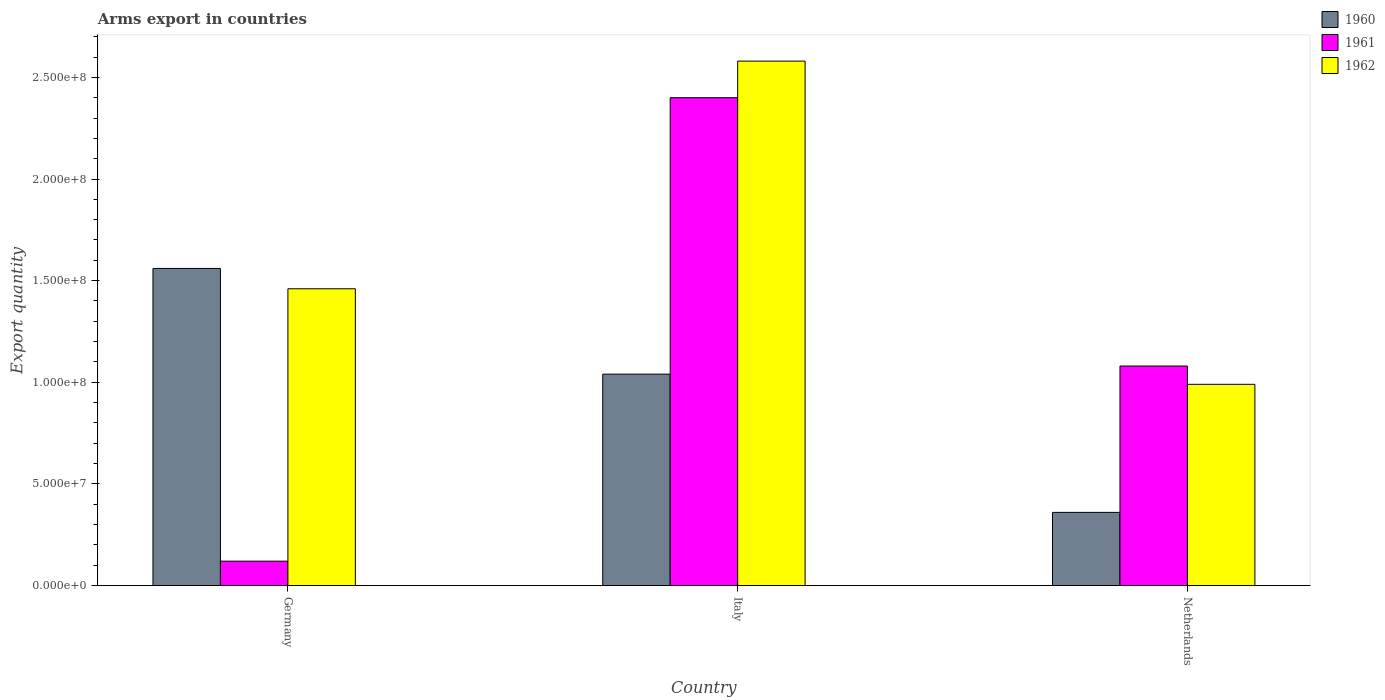Are the number of bars on each tick of the X-axis equal?
Your response must be concise. Yes. What is the label of the 1st group of bars from the left?
Provide a short and direct response. Germany. What is the total arms export in 1961 in Italy?
Your answer should be compact. 2.40e+08. Across all countries, what is the maximum total arms export in 1960?
Provide a succinct answer. 1.56e+08. Across all countries, what is the minimum total arms export in 1962?
Your answer should be very brief. 9.90e+07. What is the total total arms export in 1961 in the graph?
Offer a terse response. 3.60e+08. What is the difference between the total arms export in 1962 in Germany and that in Italy?
Your response must be concise. -1.12e+08. What is the difference between the total arms export in 1960 in Italy and the total arms export in 1961 in Netherlands?
Keep it short and to the point. -4.00e+06. What is the average total arms export in 1960 per country?
Ensure brevity in your answer.  9.87e+07. What is the difference between the total arms export of/in 1960 and total arms export of/in 1961 in Netherlands?
Your response must be concise. -7.20e+07. What is the ratio of the total arms export in 1961 in Germany to that in Netherlands?
Your response must be concise. 0.11. Is the difference between the total arms export in 1960 in Italy and Netherlands greater than the difference between the total arms export in 1961 in Italy and Netherlands?
Offer a very short reply. No. What is the difference between the highest and the second highest total arms export in 1962?
Give a very brief answer. 1.12e+08. What is the difference between the highest and the lowest total arms export in 1961?
Offer a very short reply. 2.28e+08. What does the 2nd bar from the right in Italy represents?
Offer a terse response. 1961. How many countries are there in the graph?
Provide a succinct answer. 3. Does the graph contain any zero values?
Provide a succinct answer. No. Does the graph contain grids?
Offer a very short reply. No. How many legend labels are there?
Ensure brevity in your answer.  3. How are the legend labels stacked?
Give a very brief answer. Vertical. What is the title of the graph?
Your answer should be compact. Arms export in countries. What is the label or title of the X-axis?
Provide a succinct answer. Country. What is the label or title of the Y-axis?
Your answer should be compact. Export quantity. What is the Export quantity of 1960 in Germany?
Your answer should be compact. 1.56e+08. What is the Export quantity of 1961 in Germany?
Keep it short and to the point. 1.20e+07. What is the Export quantity in 1962 in Germany?
Your answer should be compact. 1.46e+08. What is the Export quantity of 1960 in Italy?
Keep it short and to the point. 1.04e+08. What is the Export quantity in 1961 in Italy?
Keep it short and to the point. 2.40e+08. What is the Export quantity in 1962 in Italy?
Keep it short and to the point. 2.58e+08. What is the Export quantity in 1960 in Netherlands?
Make the answer very short. 3.60e+07. What is the Export quantity of 1961 in Netherlands?
Offer a very short reply. 1.08e+08. What is the Export quantity in 1962 in Netherlands?
Your response must be concise. 9.90e+07. Across all countries, what is the maximum Export quantity in 1960?
Give a very brief answer. 1.56e+08. Across all countries, what is the maximum Export quantity in 1961?
Your answer should be compact. 2.40e+08. Across all countries, what is the maximum Export quantity of 1962?
Offer a terse response. 2.58e+08. Across all countries, what is the minimum Export quantity of 1960?
Ensure brevity in your answer.  3.60e+07. Across all countries, what is the minimum Export quantity of 1961?
Your response must be concise. 1.20e+07. Across all countries, what is the minimum Export quantity of 1962?
Keep it short and to the point. 9.90e+07. What is the total Export quantity in 1960 in the graph?
Give a very brief answer. 2.96e+08. What is the total Export quantity of 1961 in the graph?
Provide a short and direct response. 3.60e+08. What is the total Export quantity in 1962 in the graph?
Your response must be concise. 5.03e+08. What is the difference between the Export quantity of 1960 in Germany and that in Italy?
Keep it short and to the point. 5.20e+07. What is the difference between the Export quantity in 1961 in Germany and that in Italy?
Give a very brief answer. -2.28e+08. What is the difference between the Export quantity of 1962 in Germany and that in Italy?
Your answer should be very brief. -1.12e+08. What is the difference between the Export quantity of 1960 in Germany and that in Netherlands?
Offer a terse response. 1.20e+08. What is the difference between the Export quantity in 1961 in Germany and that in Netherlands?
Make the answer very short. -9.60e+07. What is the difference between the Export quantity in 1962 in Germany and that in Netherlands?
Ensure brevity in your answer.  4.70e+07. What is the difference between the Export quantity of 1960 in Italy and that in Netherlands?
Your answer should be compact. 6.80e+07. What is the difference between the Export quantity in 1961 in Italy and that in Netherlands?
Your answer should be very brief. 1.32e+08. What is the difference between the Export quantity of 1962 in Italy and that in Netherlands?
Keep it short and to the point. 1.59e+08. What is the difference between the Export quantity of 1960 in Germany and the Export quantity of 1961 in Italy?
Keep it short and to the point. -8.40e+07. What is the difference between the Export quantity of 1960 in Germany and the Export quantity of 1962 in Italy?
Provide a short and direct response. -1.02e+08. What is the difference between the Export quantity in 1961 in Germany and the Export quantity in 1962 in Italy?
Keep it short and to the point. -2.46e+08. What is the difference between the Export quantity of 1960 in Germany and the Export quantity of 1961 in Netherlands?
Offer a terse response. 4.80e+07. What is the difference between the Export quantity of 1960 in Germany and the Export quantity of 1962 in Netherlands?
Ensure brevity in your answer.  5.70e+07. What is the difference between the Export quantity of 1961 in Germany and the Export quantity of 1962 in Netherlands?
Provide a succinct answer. -8.70e+07. What is the difference between the Export quantity in 1960 in Italy and the Export quantity in 1961 in Netherlands?
Offer a terse response. -4.00e+06. What is the difference between the Export quantity of 1960 in Italy and the Export quantity of 1962 in Netherlands?
Your answer should be compact. 5.00e+06. What is the difference between the Export quantity in 1961 in Italy and the Export quantity in 1962 in Netherlands?
Make the answer very short. 1.41e+08. What is the average Export quantity of 1960 per country?
Your answer should be compact. 9.87e+07. What is the average Export quantity in 1961 per country?
Make the answer very short. 1.20e+08. What is the average Export quantity of 1962 per country?
Keep it short and to the point. 1.68e+08. What is the difference between the Export quantity of 1960 and Export quantity of 1961 in Germany?
Provide a succinct answer. 1.44e+08. What is the difference between the Export quantity in 1961 and Export quantity in 1962 in Germany?
Offer a terse response. -1.34e+08. What is the difference between the Export quantity of 1960 and Export quantity of 1961 in Italy?
Your answer should be very brief. -1.36e+08. What is the difference between the Export quantity in 1960 and Export quantity in 1962 in Italy?
Your answer should be compact. -1.54e+08. What is the difference between the Export quantity of 1961 and Export quantity of 1962 in Italy?
Your answer should be very brief. -1.80e+07. What is the difference between the Export quantity of 1960 and Export quantity of 1961 in Netherlands?
Offer a very short reply. -7.20e+07. What is the difference between the Export quantity of 1960 and Export quantity of 1962 in Netherlands?
Your answer should be very brief. -6.30e+07. What is the difference between the Export quantity in 1961 and Export quantity in 1962 in Netherlands?
Your answer should be very brief. 9.00e+06. What is the ratio of the Export quantity in 1960 in Germany to that in Italy?
Provide a short and direct response. 1.5. What is the ratio of the Export quantity in 1961 in Germany to that in Italy?
Your answer should be very brief. 0.05. What is the ratio of the Export quantity in 1962 in Germany to that in Italy?
Ensure brevity in your answer.  0.57. What is the ratio of the Export quantity of 1960 in Germany to that in Netherlands?
Your answer should be compact. 4.33. What is the ratio of the Export quantity of 1962 in Germany to that in Netherlands?
Make the answer very short. 1.47. What is the ratio of the Export quantity of 1960 in Italy to that in Netherlands?
Your answer should be very brief. 2.89. What is the ratio of the Export quantity in 1961 in Italy to that in Netherlands?
Your answer should be compact. 2.22. What is the ratio of the Export quantity in 1962 in Italy to that in Netherlands?
Provide a succinct answer. 2.61. What is the difference between the highest and the second highest Export quantity in 1960?
Offer a terse response. 5.20e+07. What is the difference between the highest and the second highest Export quantity of 1961?
Your answer should be compact. 1.32e+08. What is the difference between the highest and the second highest Export quantity of 1962?
Provide a succinct answer. 1.12e+08. What is the difference between the highest and the lowest Export quantity of 1960?
Your response must be concise. 1.20e+08. What is the difference between the highest and the lowest Export quantity in 1961?
Ensure brevity in your answer.  2.28e+08. What is the difference between the highest and the lowest Export quantity of 1962?
Offer a terse response. 1.59e+08. 